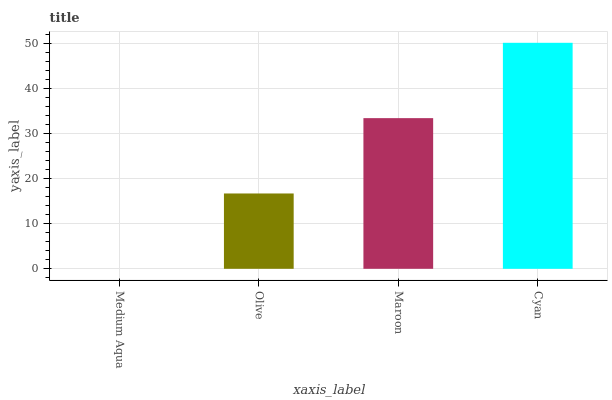Is Medium Aqua the minimum?
Answer yes or no. Yes. Is Cyan the maximum?
Answer yes or no. Yes. Is Olive the minimum?
Answer yes or no. No. Is Olive the maximum?
Answer yes or no. No. Is Olive greater than Medium Aqua?
Answer yes or no. Yes. Is Medium Aqua less than Olive?
Answer yes or no. Yes. Is Medium Aqua greater than Olive?
Answer yes or no. No. Is Olive less than Medium Aqua?
Answer yes or no. No. Is Maroon the high median?
Answer yes or no. Yes. Is Olive the low median?
Answer yes or no. Yes. Is Medium Aqua the high median?
Answer yes or no. No. Is Maroon the low median?
Answer yes or no. No. 